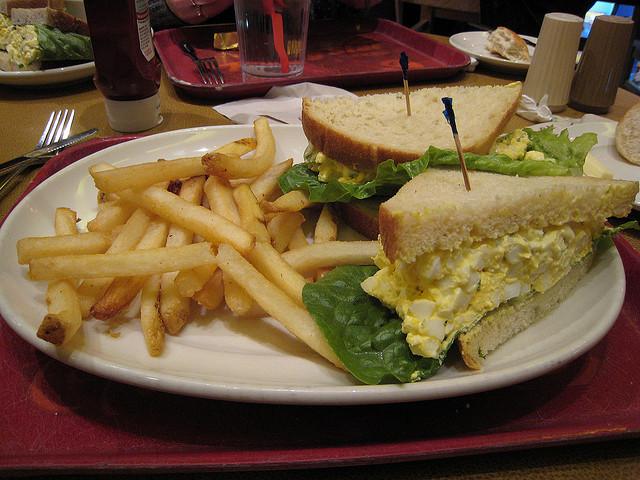Do you see any slices of bread?
Keep it brief. Yes. How many fries are on the plate?
Be succinct. 25. What color are the napkins?
Concise answer only. White. What sort of cuisine is this?
Answer briefly. American. How many calories?
Short answer required. 300. What type of food is this?
Give a very brief answer. Sandwich. Is there anything to drink?
Give a very brief answer. Yes. Which of the foods pictured is grown underground?
Be succinct. Potato. What vegetable is on this plate?
Write a very short answer. Lettuce. Are the fries making out with each other?
Concise answer only. No. How many plates can you see?
Be succinct. 1. What type of protein is this?
Be succinct. Egg. What is above the lettuce on the sandwich?
Write a very short answer. Egg salad. Is the bread toasted?
Short answer required. No. What is the food on the plate?
Keep it brief. Egg salad sandwich and fries. Is the bacon on this sandwich?
Short answer required. No. How many different types of food?
Keep it brief. 2. What type of food dish is this?
Quick response, please. Sandwich. How can you tell the French Fries are being shared between people?
Concise answer only. There are lot. What kind of potatoes are on the plate?
Quick response, please. French fries. Is the portion of waffle fries about equal to the size of the sandwich?
Short answer required. Yes. What kind of bread is that?
Short answer required. White. What is the green vegetable in this photo?
Keep it brief. Lettuce. What foods here are high in carbohydrates?
Short answer required. Fries. What is the text etched in the edge of the plate?
Concise answer only. Nothing. What kind of sandwich is this?
Answer briefly. Egg salad. What is mainly featured?
Keep it brief. Sandwich. Does this meal look healthy?
Concise answer only. No. What type of sandwich is this?
Give a very brief answer. Egg salad. What food is on the plate?
Give a very brief answer. Sandwich. What kind of fries are on the plate?
Keep it brief. French. What type of vegetable is on the dish?
Answer briefly. Lettuce. Is there meat in the picture?
Answer briefly. No. Is there bacon on this sandwich?
Keep it brief. No. Is there any meat in the meal?
Answer briefly. No. What is in the sandwich?
Give a very brief answer. Egg salad. Is there broccoli in the picture?
Quick response, please. No. What kind of food is this?
Write a very short answer. Sandwich. Is there broccoli?
Keep it brief. No. Is there an empty plate on the table?
Answer briefly. No. Is this meal served on a plate?
Give a very brief answer. Yes. Is the filling beyond the bread crust?
Short answer required. Yes. Where is the food?
Concise answer only. On plate. What tomato-based condiment is usually paired with the side dish shown?
Short answer required. Ketchup. What is the green food?
Be succinct. Lettuce. Is there shrimp on the plate?
Keep it brief. No. Is the food laying on what color napkin?
Answer briefly. White. Is there seafood in the image?
Quick response, please. No. What is the green stuff?
Keep it brief. Lettuce. Where is the silverware?
Give a very brief answer. Left. Is this a sandwich?
Write a very short answer. Yes. Where are the sausages?
Concise answer only. Nowhere. What are the yellow items in this dish?
Short answer required. Fries. Is the sandwich vegan?
Be succinct. No. Do you have blue plates?
Answer briefly. No. What shape is the plate?
Quick response, please. Round. What is the green vegetable?
Answer briefly. Lettuce. 